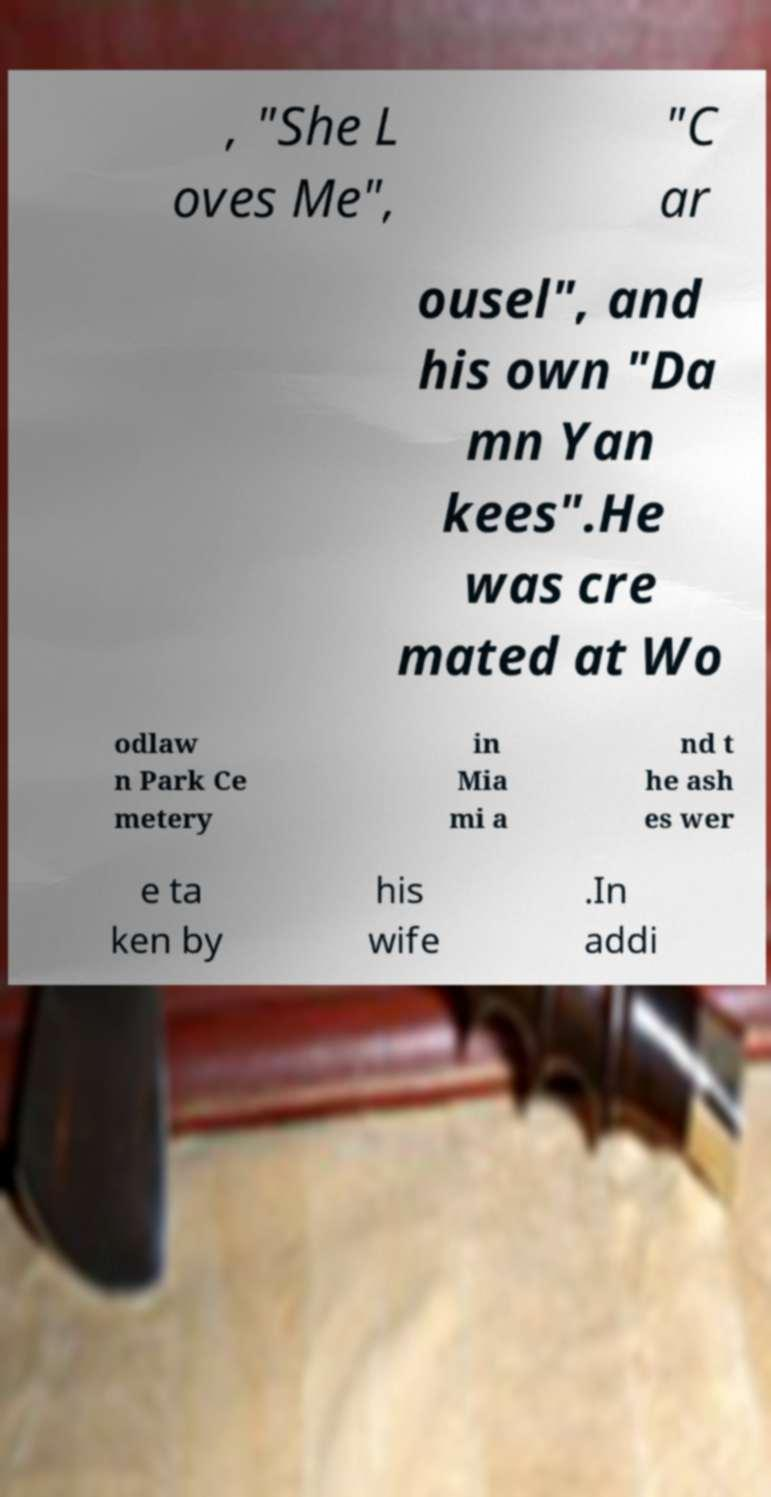Please identify and transcribe the text found in this image. , "She L oves Me", "C ar ousel", and his own "Da mn Yan kees".He was cre mated at Wo odlaw n Park Ce metery in Mia mi a nd t he ash es wer e ta ken by his wife .In addi 